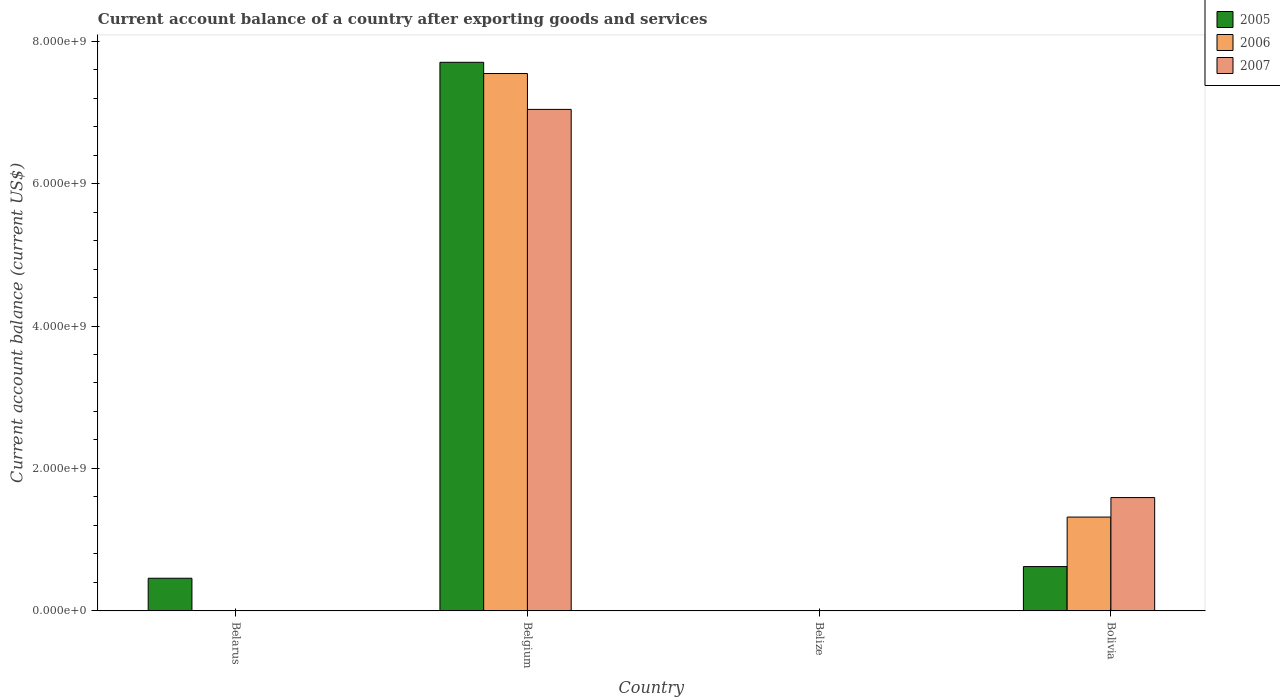How many different coloured bars are there?
Your answer should be compact. 3. Are the number of bars per tick equal to the number of legend labels?
Keep it short and to the point. No. Are the number of bars on each tick of the X-axis equal?
Your answer should be compact. No. How many bars are there on the 2nd tick from the left?
Offer a terse response. 3. What is the label of the 3rd group of bars from the left?
Offer a very short reply. Belize. Across all countries, what is the maximum account balance in 2005?
Offer a terse response. 7.70e+09. Across all countries, what is the minimum account balance in 2006?
Keep it short and to the point. 0. In which country was the account balance in 2005 maximum?
Keep it short and to the point. Belgium. What is the total account balance in 2006 in the graph?
Offer a very short reply. 8.86e+09. What is the difference between the account balance in 2005 in Belgium and the account balance in 2007 in Bolivia?
Offer a very short reply. 6.11e+09. What is the average account balance in 2005 per country?
Give a very brief answer. 2.20e+09. What is the difference between the account balance of/in 2005 and account balance of/in 2006 in Belgium?
Keep it short and to the point. 1.58e+08. Is the account balance in 2005 in Belarus less than that in Belgium?
Offer a very short reply. Yes. Is the difference between the account balance in 2005 in Belgium and Bolivia greater than the difference between the account balance in 2006 in Belgium and Bolivia?
Ensure brevity in your answer.  Yes. What is the difference between the highest and the second highest account balance in 2005?
Ensure brevity in your answer.  -1.64e+08. What is the difference between the highest and the lowest account balance in 2006?
Provide a succinct answer. 7.55e+09. In how many countries, is the account balance in 2006 greater than the average account balance in 2006 taken over all countries?
Your response must be concise. 1. Is the sum of the account balance in 2006 in Belgium and Bolivia greater than the maximum account balance in 2005 across all countries?
Your answer should be compact. Yes. How many bars are there?
Your answer should be compact. 7. Does the graph contain any zero values?
Make the answer very short. Yes. How many legend labels are there?
Provide a succinct answer. 3. What is the title of the graph?
Provide a succinct answer. Current account balance of a country after exporting goods and services. Does "2005" appear as one of the legend labels in the graph?
Provide a short and direct response. Yes. What is the label or title of the X-axis?
Offer a very short reply. Country. What is the label or title of the Y-axis?
Provide a succinct answer. Current account balance (current US$). What is the Current account balance (current US$) of 2005 in Belarus?
Keep it short and to the point. 4.59e+08. What is the Current account balance (current US$) of 2005 in Belgium?
Provide a short and direct response. 7.70e+09. What is the Current account balance (current US$) of 2006 in Belgium?
Ensure brevity in your answer.  7.55e+09. What is the Current account balance (current US$) of 2007 in Belgium?
Your answer should be very brief. 7.04e+09. What is the Current account balance (current US$) in 2005 in Belize?
Give a very brief answer. 0. What is the Current account balance (current US$) in 2007 in Belize?
Your answer should be compact. 0. What is the Current account balance (current US$) of 2005 in Bolivia?
Your answer should be very brief. 6.22e+08. What is the Current account balance (current US$) in 2006 in Bolivia?
Give a very brief answer. 1.32e+09. What is the Current account balance (current US$) of 2007 in Bolivia?
Make the answer very short. 1.59e+09. Across all countries, what is the maximum Current account balance (current US$) of 2005?
Provide a succinct answer. 7.70e+09. Across all countries, what is the maximum Current account balance (current US$) in 2006?
Your answer should be compact. 7.55e+09. Across all countries, what is the maximum Current account balance (current US$) of 2007?
Make the answer very short. 7.04e+09. Across all countries, what is the minimum Current account balance (current US$) in 2007?
Provide a short and direct response. 0. What is the total Current account balance (current US$) of 2005 in the graph?
Make the answer very short. 8.78e+09. What is the total Current account balance (current US$) of 2006 in the graph?
Your answer should be very brief. 8.86e+09. What is the total Current account balance (current US$) of 2007 in the graph?
Offer a very short reply. 8.63e+09. What is the difference between the Current account balance (current US$) of 2005 in Belarus and that in Belgium?
Provide a short and direct response. -7.24e+09. What is the difference between the Current account balance (current US$) in 2005 in Belarus and that in Bolivia?
Offer a terse response. -1.64e+08. What is the difference between the Current account balance (current US$) in 2005 in Belgium and that in Bolivia?
Keep it short and to the point. 7.08e+09. What is the difference between the Current account balance (current US$) in 2006 in Belgium and that in Bolivia?
Your answer should be very brief. 6.23e+09. What is the difference between the Current account balance (current US$) of 2007 in Belgium and that in Bolivia?
Ensure brevity in your answer.  5.45e+09. What is the difference between the Current account balance (current US$) in 2005 in Belarus and the Current account balance (current US$) in 2006 in Belgium?
Offer a terse response. -7.09e+09. What is the difference between the Current account balance (current US$) in 2005 in Belarus and the Current account balance (current US$) in 2007 in Belgium?
Offer a terse response. -6.58e+09. What is the difference between the Current account balance (current US$) in 2005 in Belarus and the Current account balance (current US$) in 2006 in Bolivia?
Make the answer very short. -8.59e+08. What is the difference between the Current account balance (current US$) of 2005 in Belarus and the Current account balance (current US$) of 2007 in Bolivia?
Provide a short and direct response. -1.13e+09. What is the difference between the Current account balance (current US$) in 2005 in Belgium and the Current account balance (current US$) in 2006 in Bolivia?
Offer a very short reply. 6.39e+09. What is the difference between the Current account balance (current US$) in 2005 in Belgium and the Current account balance (current US$) in 2007 in Bolivia?
Your response must be concise. 6.11e+09. What is the difference between the Current account balance (current US$) of 2006 in Belgium and the Current account balance (current US$) of 2007 in Bolivia?
Ensure brevity in your answer.  5.95e+09. What is the average Current account balance (current US$) of 2005 per country?
Your response must be concise. 2.20e+09. What is the average Current account balance (current US$) of 2006 per country?
Ensure brevity in your answer.  2.22e+09. What is the average Current account balance (current US$) in 2007 per country?
Make the answer very short. 2.16e+09. What is the difference between the Current account balance (current US$) in 2005 and Current account balance (current US$) in 2006 in Belgium?
Provide a succinct answer. 1.58e+08. What is the difference between the Current account balance (current US$) in 2005 and Current account balance (current US$) in 2007 in Belgium?
Your answer should be compact. 6.61e+08. What is the difference between the Current account balance (current US$) of 2006 and Current account balance (current US$) of 2007 in Belgium?
Provide a short and direct response. 5.04e+08. What is the difference between the Current account balance (current US$) of 2005 and Current account balance (current US$) of 2006 in Bolivia?
Your answer should be very brief. -6.95e+08. What is the difference between the Current account balance (current US$) of 2005 and Current account balance (current US$) of 2007 in Bolivia?
Offer a very short reply. -9.69e+08. What is the difference between the Current account balance (current US$) of 2006 and Current account balance (current US$) of 2007 in Bolivia?
Offer a very short reply. -2.74e+08. What is the ratio of the Current account balance (current US$) in 2005 in Belarus to that in Belgium?
Offer a terse response. 0.06. What is the ratio of the Current account balance (current US$) of 2005 in Belarus to that in Bolivia?
Make the answer very short. 0.74. What is the ratio of the Current account balance (current US$) in 2005 in Belgium to that in Bolivia?
Keep it short and to the point. 12.37. What is the ratio of the Current account balance (current US$) of 2006 in Belgium to that in Bolivia?
Your answer should be compact. 5.73. What is the ratio of the Current account balance (current US$) in 2007 in Belgium to that in Bolivia?
Provide a short and direct response. 4.42. What is the difference between the highest and the second highest Current account balance (current US$) of 2005?
Ensure brevity in your answer.  7.08e+09. What is the difference between the highest and the lowest Current account balance (current US$) in 2005?
Your answer should be compact. 7.70e+09. What is the difference between the highest and the lowest Current account balance (current US$) in 2006?
Your response must be concise. 7.55e+09. What is the difference between the highest and the lowest Current account balance (current US$) of 2007?
Give a very brief answer. 7.04e+09. 